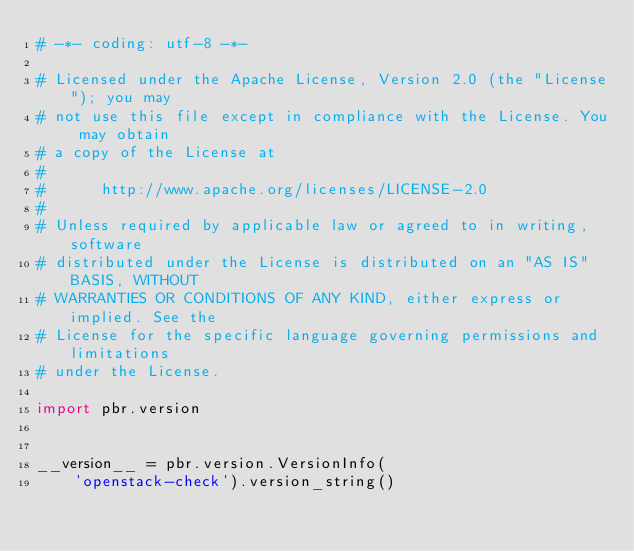<code> <loc_0><loc_0><loc_500><loc_500><_Python_># -*- coding: utf-8 -*-

# Licensed under the Apache License, Version 2.0 (the "License"); you may
# not use this file except in compliance with the License. You may obtain
# a copy of the License at
#
#      http://www.apache.org/licenses/LICENSE-2.0
#
# Unless required by applicable law or agreed to in writing, software
# distributed under the License is distributed on an "AS IS" BASIS, WITHOUT
# WARRANTIES OR CONDITIONS OF ANY KIND, either express or implied. See the
# License for the specific language governing permissions and limitations
# under the License.

import pbr.version


__version__ = pbr.version.VersionInfo(
    'openstack-check').version_string()
</code> 